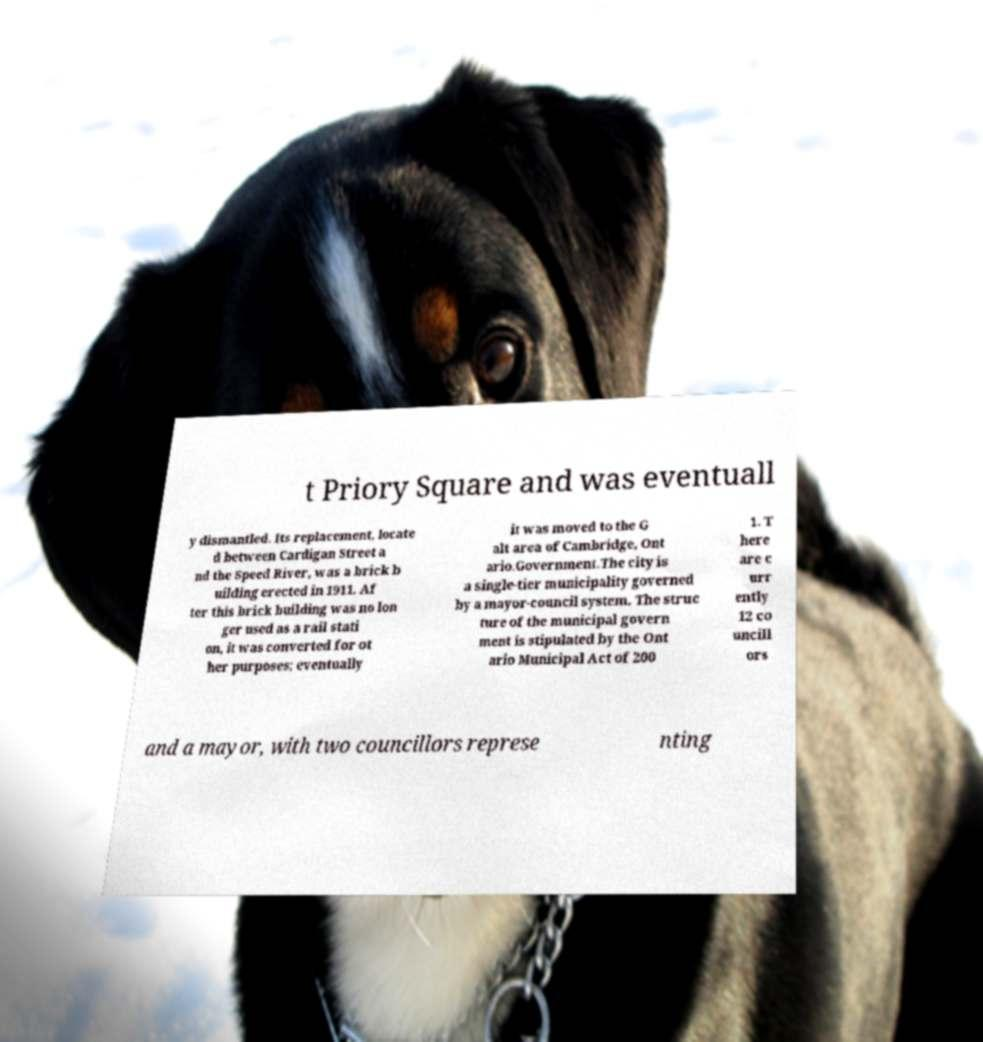What messages or text are displayed in this image? I need them in a readable, typed format. t Priory Square and was eventuall y dismantled. Its replacement, locate d between Cardigan Street a nd the Speed River, was a brick b uilding erected in 1911. Af ter this brick building was no lon ger used as a rail stati on, it was converted for ot her purposes; eventually it was moved to the G alt area of Cambridge, Ont ario.Government.The city is a single-tier municipality governed by a mayor-council system. The struc ture of the municipal govern ment is stipulated by the Ont ario Municipal Act of 200 1. T here are c urr ently 12 co uncill ors and a mayor, with two councillors represe nting 